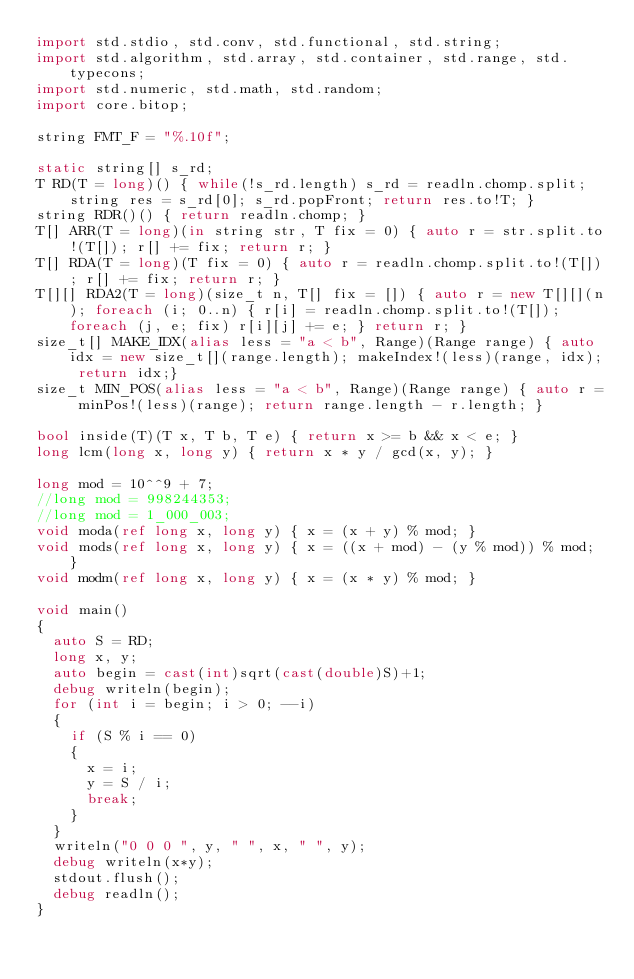<code> <loc_0><loc_0><loc_500><loc_500><_D_>import std.stdio, std.conv, std.functional, std.string;
import std.algorithm, std.array, std.container, std.range, std.typecons;
import std.numeric, std.math, std.random;
import core.bitop;

string FMT_F = "%.10f";

static string[] s_rd;
T RD(T = long)() { while(!s_rd.length) s_rd = readln.chomp.split; string res = s_rd[0]; s_rd.popFront; return res.to!T; }
string RDR()() { return readln.chomp; }
T[] ARR(T = long)(in string str, T fix = 0) { auto r = str.split.to!(T[]); r[] += fix; return r; }
T[] RDA(T = long)(T fix = 0) { auto r = readln.chomp.split.to!(T[]); r[] += fix; return r; }
T[][] RDA2(T = long)(size_t n, T[] fix = []) { auto r = new T[][](n); foreach (i; 0..n) { r[i] = readln.chomp.split.to!(T[]); foreach (j, e; fix) r[i][j] += e; } return r; }
size_t[] MAKE_IDX(alias less = "a < b", Range)(Range range) { auto idx = new size_t[](range.length); makeIndex!(less)(range, idx); return idx;}
size_t MIN_POS(alias less = "a < b", Range)(Range range) { auto r = minPos!(less)(range); return range.length - r.length; }

bool inside(T)(T x, T b, T e) { return x >= b && x < e; }
long lcm(long x, long y) { return x * y / gcd(x, y); }

long mod = 10^^9 + 7;
//long mod = 998244353;
//long mod = 1_000_003;
void moda(ref long x, long y) { x = (x + y) % mod; }
void mods(ref long x, long y) { x = ((x + mod) - (y % mod)) % mod; }
void modm(ref long x, long y) { x = (x * y) % mod; }

void main()
{
	auto S = RD;
	long x, y;
	auto begin = cast(int)sqrt(cast(double)S)+1;
	debug writeln(begin);
	for (int i = begin; i > 0; --i)
	{
		if (S % i == 0)
		{
			x = i;
			y = S / i;
			break;
		}
	}
	writeln("0 0 0 ", y, " ", x, " ", y);
	debug writeln(x*y);
	stdout.flush();
	debug readln();
}
</code> 